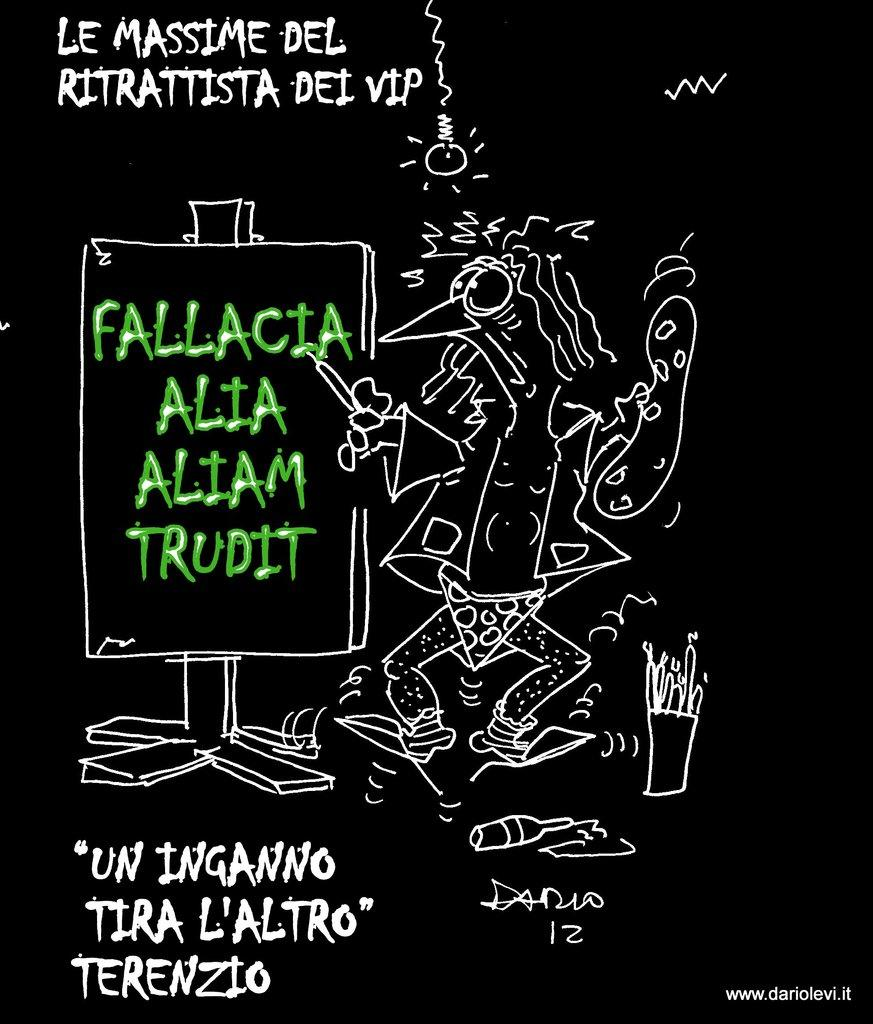<image>
Provide a brief description of the given image. A black and white picture with FALLACIA ALIA ALIAM TRUDIT in green font 